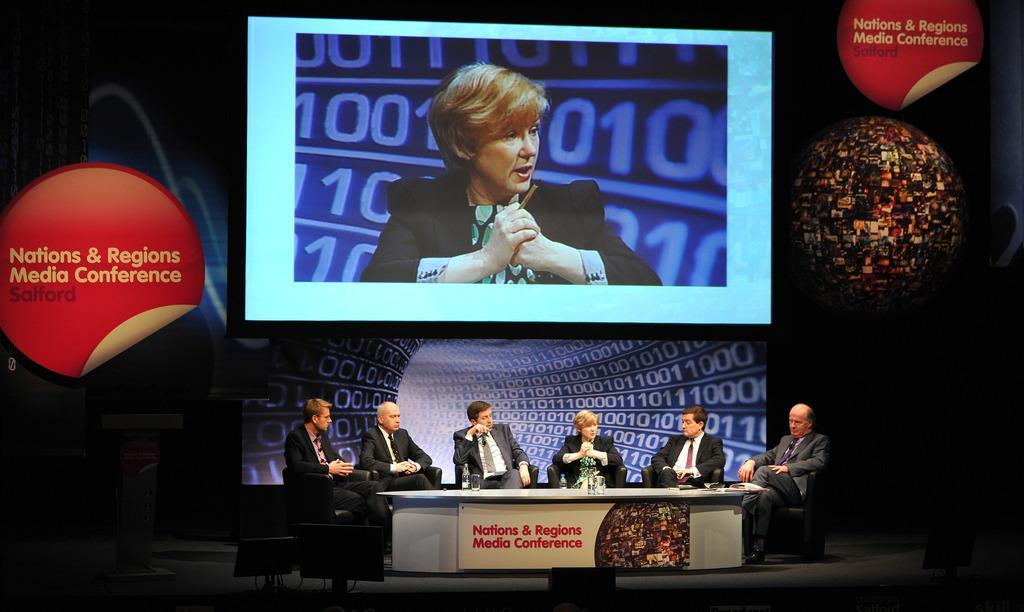How would you summarize this image in a sentence or two? In the picture we can see six people are sitting in the chairs, five are men and one woman and they are wearing blazers, ties and shirts and near to them we can see a desk on it we can see some glasses of water and behind them we can see a animated screen and on the top of it we can see another screen with a woman image on it. 